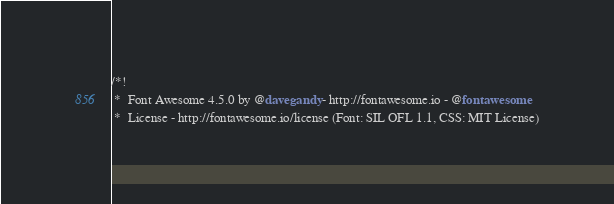<code> <loc_0><loc_0><loc_500><loc_500><_CSS_>/*!
 *  Font Awesome 4.5.0 by @davegandy - http://fontawesome.io - @fontawesome
 *  License - http://fontawesome.io/license (Font: SIL OFL 1.1, CSS: MIT License)</code> 